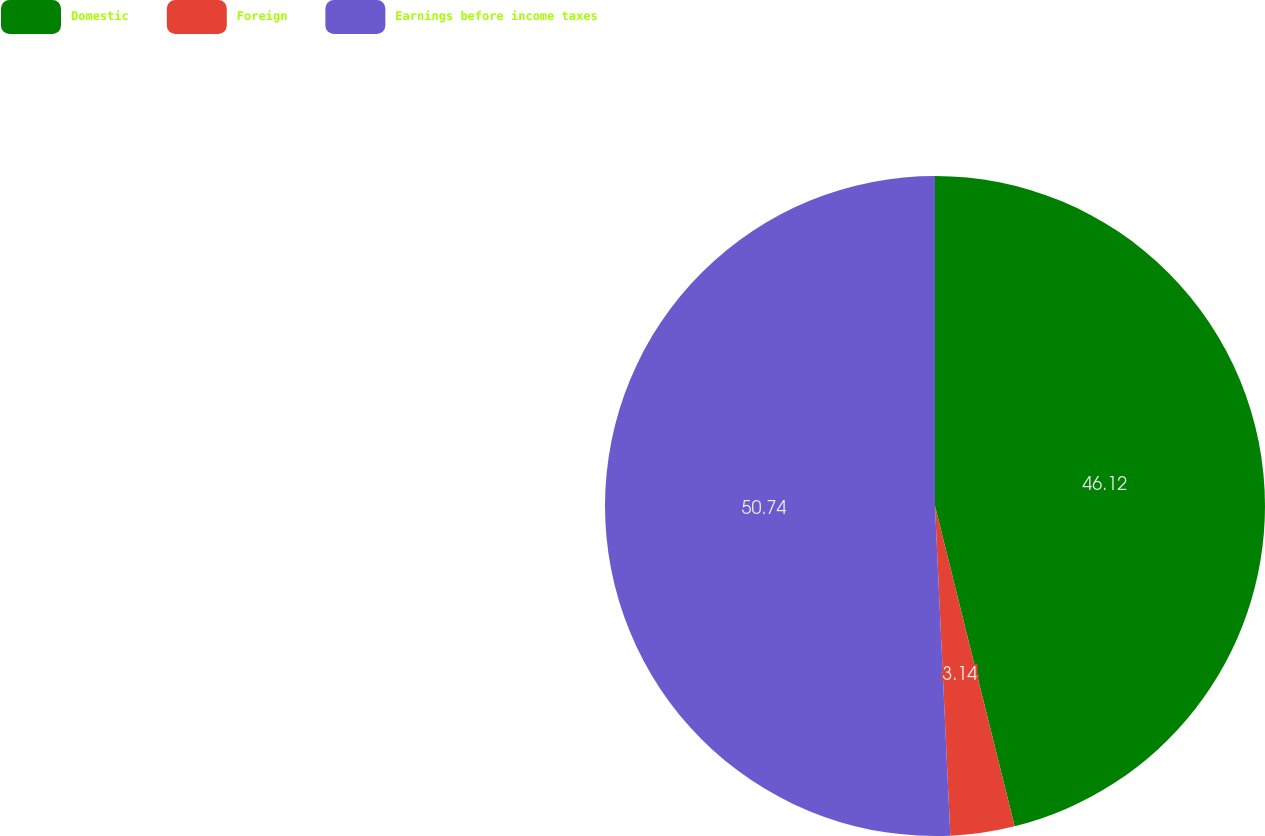<chart> <loc_0><loc_0><loc_500><loc_500><pie_chart><fcel>Domestic<fcel>Foreign<fcel>Earnings before income taxes<nl><fcel>46.12%<fcel>3.14%<fcel>50.74%<nl></chart> 